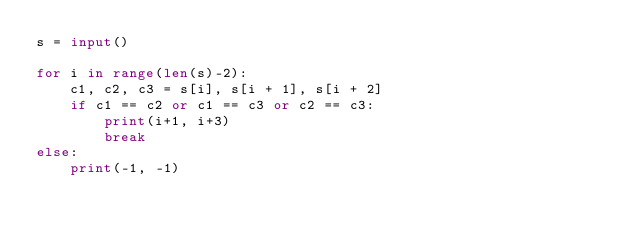<code> <loc_0><loc_0><loc_500><loc_500><_Python_>s = input()

for i in range(len(s)-2):
    c1, c2, c3 = s[i], s[i + 1], s[i + 2]
    if c1 == c2 or c1 == c3 or c2 == c3:
        print(i+1, i+3)
        break
else:
    print(-1, -1)
</code> 